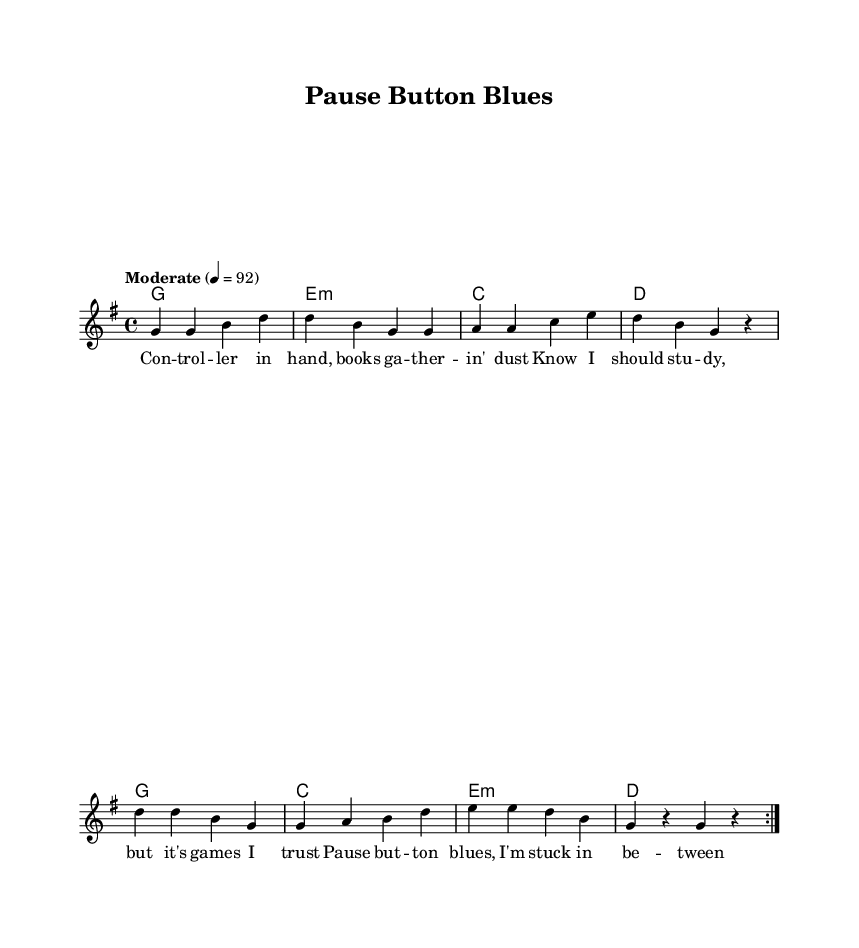What is the key signature of this music? The key signature is G major, which has one sharp (F#) noted in the key signature section of the sheet.
Answer: G major What is the time signature of this music? The time signature is 4/4, indicated at the beginning of the score, meaning there are four beats in a measure.
Answer: 4/4 What is the tempo marking for this piece? The tempo marking is "Moderate," with a metronome marking of quarter note equals 92, instructing the performer to play at this speed.
Answer: Moderate How many repeats are indicated in the melody section? The melody section contains two repeats, as indicated by the "repeat volta 2" notation which shows that the melody should be played two times.
Answer: 2 What is the primary theme of the lyrics in this piece? The lyrics focus on the struggle with procrastination and a longing to overcome obstacles, reflecting a relatable theme of distraction versus ambition.
Answer: Procrastination What chord is played at the beginning of the harmony section? The first chord in the harmony section is G major, as indicated in the chord names below the staff at the start of the piece.
Answer: G 